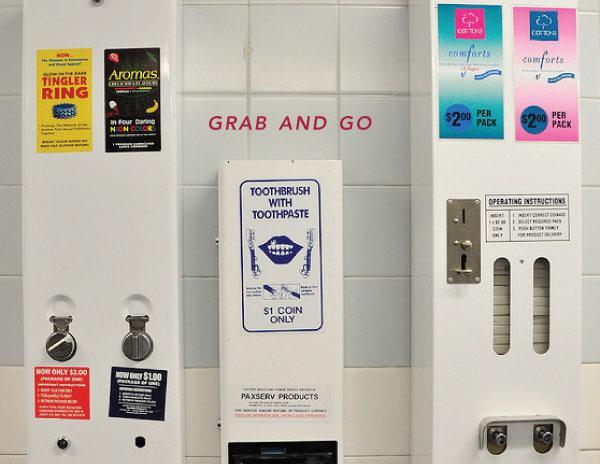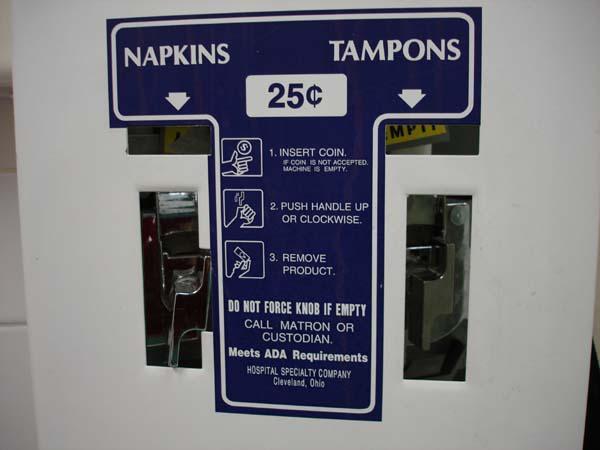The first image is the image on the left, the second image is the image on the right. For the images shown, is this caption "There are multiple vending machines, none of which are in restrooms, and there are no people." true? Answer yes or no. No. The first image is the image on the left, the second image is the image on the right. Analyze the images presented: Is the assertion "Right image includes a white vending machine that dispenses beverages." valid? Answer yes or no. No. 